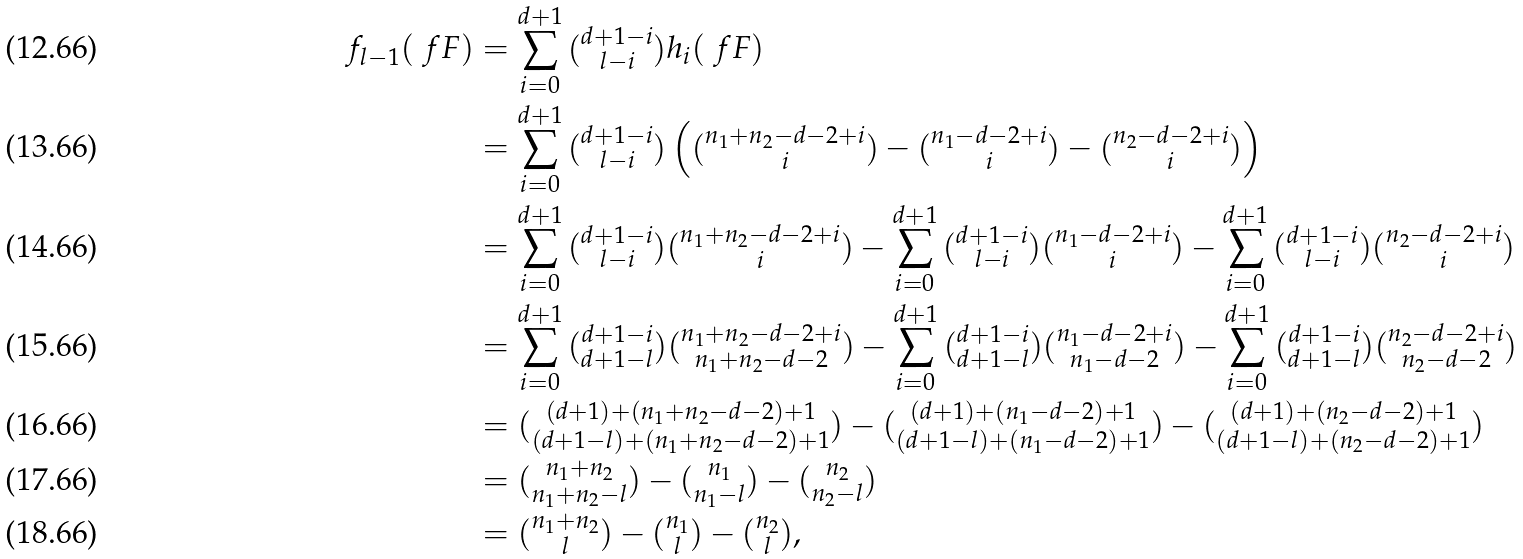Convert formula to latex. <formula><loc_0><loc_0><loc_500><loc_500>f _ { l - 1 } ( \ f F ) & = \sum _ { i = 0 } ^ { d + 1 } \tbinom { d + 1 - i } { l - i } h _ { i } ( \ f F ) \\ & = \sum _ { i = 0 } ^ { d + 1 } \tbinom { d + 1 - i } { l - i } \left ( \tbinom { n _ { 1 } + n _ { 2 } - d - 2 + i } { i } - \tbinom { n _ { 1 } - d - 2 + i } { i } - \tbinom { n _ { 2 } - d - 2 + i } { i } \right ) \\ & = \sum _ { i = 0 } ^ { d + 1 } \tbinom { d + 1 - i } { l - i } \tbinom { n _ { 1 } + n _ { 2 } - d - 2 + i } { i } - \sum _ { i = 0 } ^ { d + 1 } \tbinom { d + 1 - i } { l - i } \tbinom { n _ { 1 } - d - 2 + i } { i } - \sum _ { i = 0 } ^ { d + 1 } \tbinom { d + 1 - i } { l - i } \tbinom { n _ { 2 } - d - 2 + i } { i } \\ & = \sum _ { i = 0 } ^ { d + 1 } \tbinom { d + 1 - i } { d + 1 - l } \tbinom { n _ { 1 } + n _ { 2 } - d - 2 + i } { n _ { 1 } + n _ { 2 } - d - 2 } - \sum _ { i = 0 } ^ { d + 1 } \tbinom { d + 1 - i } { d + 1 - l } \tbinom { n _ { 1 } - d - 2 + i } { n _ { 1 } - d - 2 } - \sum _ { i = 0 } ^ { d + 1 } \tbinom { d + 1 - i } { d + 1 - l } \tbinom { n _ { 2 } - d - 2 + i } { n _ { 2 } - d - 2 } \\ & = \tbinom { ( d + 1 ) + ( n _ { 1 } + n _ { 2 } - d - 2 ) + 1 } { ( d + 1 - l ) + ( n _ { 1 } + n _ { 2 } - d - 2 ) + 1 } - \tbinom { ( d + 1 ) + ( n _ { 1 } - d - 2 ) + 1 } { ( d + 1 - l ) + ( n _ { 1 } - d - 2 ) + 1 } - \tbinom { ( d + 1 ) + ( n _ { 2 } - d - 2 ) + 1 } { ( d + 1 - l ) + ( n _ { 2 } - d - 2 ) + 1 } \\ & = \tbinom { n _ { 1 } + n _ { 2 } } { n _ { 1 } + n _ { 2 } - l } - \tbinom { n _ { 1 } } { n _ { 1 } - l } - \tbinom { n _ { 2 } } { n _ { 2 } - l } \\ & = \tbinom { n _ { 1 } + n _ { 2 } } { l } - \tbinom { n _ { 1 } } { l } - \tbinom { n _ { 2 } } { l } ,</formula> 